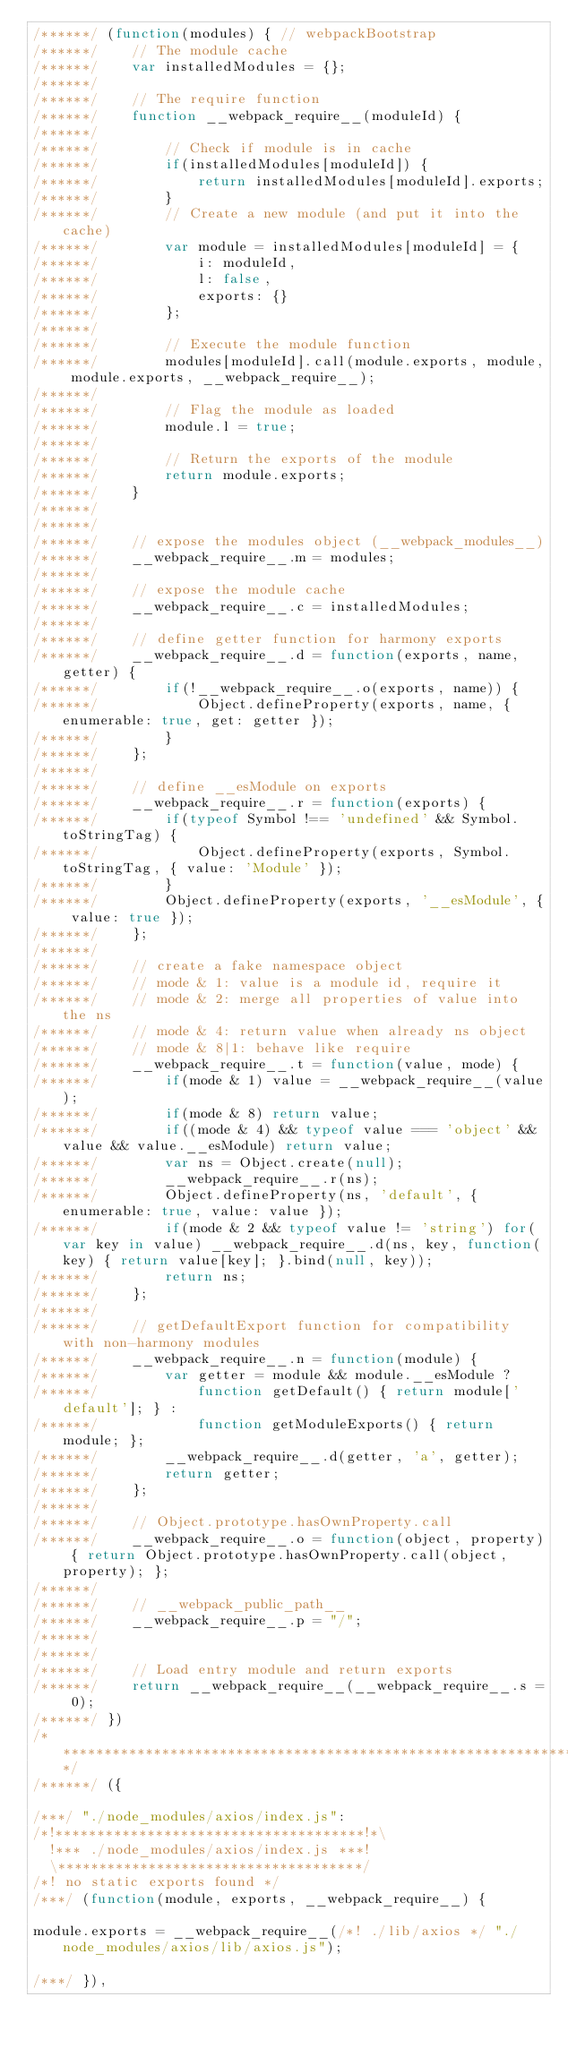<code> <loc_0><loc_0><loc_500><loc_500><_JavaScript_>/******/ (function(modules) { // webpackBootstrap
/******/ 	// The module cache
/******/ 	var installedModules = {};
/******/
/******/ 	// The require function
/******/ 	function __webpack_require__(moduleId) {
/******/
/******/ 		// Check if module is in cache
/******/ 		if(installedModules[moduleId]) {
/******/ 			return installedModules[moduleId].exports;
/******/ 		}
/******/ 		// Create a new module (and put it into the cache)
/******/ 		var module = installedModules[moduleId] = {
/******/ 			i: moduleId,
/******/ 			l: false,
/******/ 			exports: {}
/******/ 		};
/******/
/******/ 		// Execute the module function
/******/ 		modules[moduleId].call(module.exports, module, module.exports, __webpack_require__);
/******/
/******/ 		// Flag the module as loaded
/******/ 		module.l = true;
/******/
/******/ 		// Return the exports of the module
/******/ 		return module.exports;
/******/ 	}
/******/
/******/
/******/ 	// expose the modules object (__webpack_modules__)
/******/ 	__webpack_require__.m = modules;
/******/
/******/ 	// expose the module cache
/******/ 	__webpack_require__.c = installedModules;
/******/
/******/ 	// define getter function for harmony exports
/******/ 	__webpack_require__.d = function(exports, name, getter) {
/******/ 		if(!__webpack_require__.o(exports, name)) {
/******/ 			Object.defineProperty(exports, name, { enumerable: true, get: getter });
/******/ 		}
/******/ 	};
/******/
/******/ 	// define __esModule on exports
/******/ 	__webpack_require__.r = function(exports) {
/******/ 		if(typeof Symbol !== 'undefined' && Symbol.toStringTag) {
/******/ 			Object.defineProperty(exports, Symbol.toStringTag, { value: 'Module' });
/******/ 		}
/******/ 		Object.defineProperty(exports, '__esModule', { value: true });
/******/ 	};
/******/
/******/ 	// create a fake namespace object
/******/ 	// mode & 1: value is a module id, require it
/******/ 	// mode & 2: merge all properties of value into the ns
/******/ 	// mode & 4: return value when already ns object
/******/ 	// mode & 8|1: behave like require
/******/ 	__webpack_require__.t = function(value, mode) {
/******/ 		if(mode & 1) value = __webpack_require__(value);
/******/ 		if(mode & 8) return value;
/******/ 		if((mode & 4) && typeof value === 'object' && value && value.__esModule) return value;
/******/ 		var ns = Object.create(null);
/******/ 		__webpack_require__.r(ns);
/******/ 		Object.defineProperty(ns, 'default', { enumerable: true, value: value });
/******/ 		if(mode & 2 && typeof value != 'string') for(var key in value) __webpack_require__.d(ns, key, function(key) { return value[key]; }.bind(null, key));
/******/ 		return ns;
/******/ 	};
/******/
/******/ 	// getDefaultExport function for compatibility with non-harmony modules
/******/ 	__webpack_require__.n = function(module) {
/******/ 		var getter = module && module.__esModule ?
/******/ 			function getDefault() { return module['default']; } :
/******/ 			function getModuleExports() { return module; };
/******/ 		__webpack_require__.d(getter, 'a', getter);
/******/ 		return getter;
/******/ 	};
/******/
/******/ 	// Object.prototype.hasOwnProperty.call
/******/ 	__webpack_require__.o = function(object, property) { return Object.prototype.hasOwnProperty.call(object, property); };
/******/
/******/ 	// __webpack_public_path__
/******/ 	__webpack_require__.p = "/";
/******/
/******/
/******/ 	// Load entry module and return exports
/******/ 	return __webpack_require__(__webpack_require__.s = 0);
/******/ })
/************************************************************************/
/******/ ({

/***/ "./node_modules/axios/index.js":
/*!*************************************!*\
  !*** ./node_modules/axios/index.js ***!
  \*************************************/
/*! no static exports found */
/***/ (function(module, exports, __webpack_require__) {

module.exports = __webpack_require__(/*! ./lib/axios */ "./node_modules/axios/lib/axios.js");

/***/ }),
</code> 